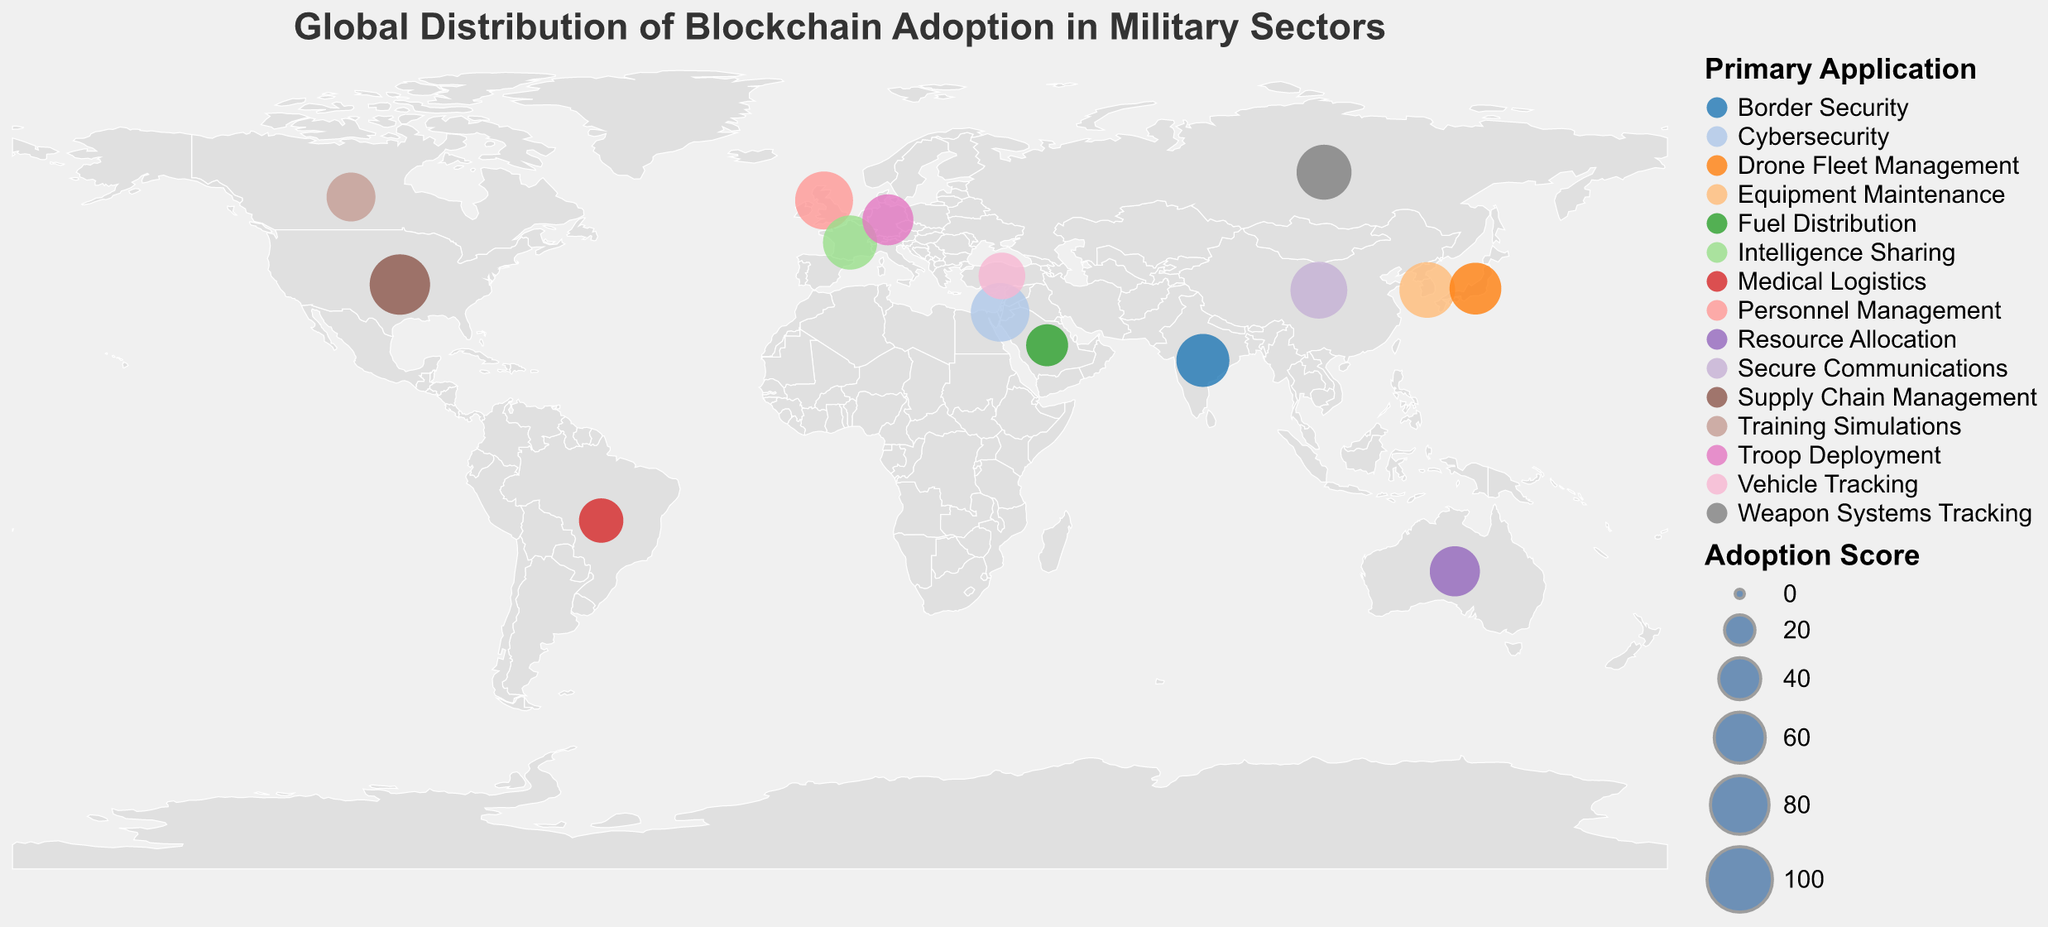What is the primary application of blockchain in Israel? By examining the figure, we see that for Israel, the primary application of blockchain is indicated in the tooltip when hovering over Israel's data point.
Answer: Cybersecurity Which country has the highest blockchain adoption score in the military sectors? The countries are represented by circles of different sizes. The largest circle is associated with the United States, and the tooltip shows an adoption score of 85.
Answer: United States Compare the blockchain adoption scores between China and France. Which one is higher and by how much? China and France have scores of 75 and 68, respectively. The difference between these scores is 75 - 68 = 7.
Answer: China, by 7 Which countries have a blockchain adoption score below 50? By looking at the data points with smaller-sized circles and reading the tooltips, we can see that Brazil (45) and Saudi Arabia (40) have adoption scores below 50.
Answer: Brazil and Saudi Arabia What is the average blockchain adoption score of the given countries? Sum all the adoption scores and divide by the number of countries: (85 + 75 + 70 + 80 + 78 + 65 + 72 + 68 + 62 + 60 + 58 + 55 + 50 + 45 + 40) / 15 = 67.2.
Answer: 67.2 What is the primary application of blockchain in countries with adoption scores higher than 70? The countries with adoption scores higher than 70 are the United States (Supply Chain Management), China (Secure Communications), Israel (Cybersecurity), and the United Kingdom (Personnel Management).
Answer: Supply Chain Management, Secure Communications, Cybersecurity, Personnel Management What is the title of the plot? The title appears at the top of the plot and reads "Global Distribution of Blockchain Adoption in Military Sectors."
Answer: Global Distribution of Blockchain Adoption in Military Sectors Are there more countries using blockchain for Secure Communications or for Medical Logistics? By examining the color coding and the tooltips, only China uses blockchain for Secure Communications, and only Brazil uses it for Medical Logistics.
Answer: Same number Which country focuses on using blockchain for drone fleet management? By hovering over the data points and reading the tooltips, we see that Japan's primary application is Drone Fleet Management.
Answer: Japan 